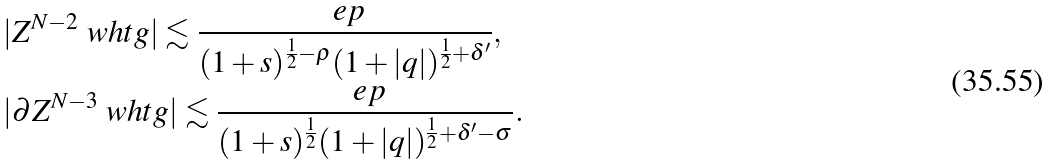Convert formula to latex. <formula><loc_0><loc_0><loc_500><loc_500>& | Z ^ { N - 2 } \ w h t g | \lesssim \frac { \ e p } { ( 1 + s ) ^ { \frac { 1 } { 2 } - \rho } ( 1 + | q | ) ^ { \frac { 1 } { 2 } + \delta ^ { \prime } } } , \\ & | \partial Z ^ { N - 3 } \ w h t g | \lesssim \frac { \ e p } { ( 1 + s ) ^ { \frac { 1 } { 2 } } ( 1 + | q | ) ^ { \frac { 1 } { 2 } + \delta ^ { \prime } - \sigma } } .</formula> 